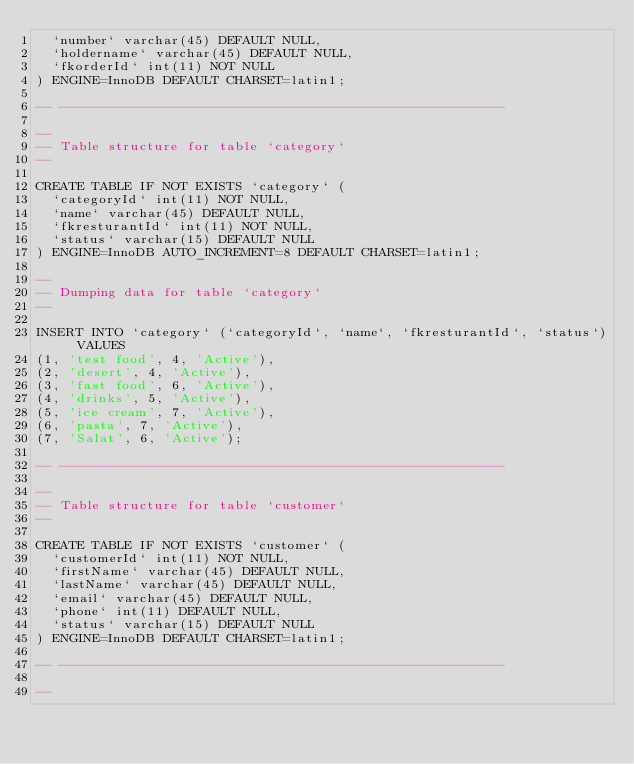<code> <loc_0><loc_0><loc_500><loc_500><_SQL_>  `number` varchar(45) DEFAULT NULL,
  `holdername` varchar(45) DEFAULT NULL,
  `fkorderId` int(11) NOT NULL
) ENGINE=InnoDB DEFAULT CHARSET=latin1;

-- --------------------------------------------------------

--
-- Table structure for table `category`
--

CREATE TABLE IF NOT EXISTS `category` (
  `categoryId` int(11) NOT NULL,
  `name` varchar(45) DEFAULT NULL,
  `fkresturantId` int(11) NOT NULL,
  `status` varchar(15) DEFAULT NULL
) ENGINE=InnoDB AUTO_INCREMENT=8 DEFAULT CHARSET=latin1;

--
-- Dumping data for table `category`
--

INSERT INTO `category` (`categoryId`, `name`, `fkresturantId`, `status`) VALUES
(1, 'test food', 4, 'Active'),
(2, 'desert', 4, 'Active'),
(3, 'fast food', 6, 'Active'),
(4, 'drinks', 5, 'Active'),
(5, 'ice cream', 7, 'Active'),
(6, 'pasta', 7, 'Active'),
(7, 'Salat', 6, 'Active');

-- --------------------------------------------------------

--
-- Table structure for table `customer`
--

CREATE TABLE IF NOT EXISTS `customer` (
  `customerId` int(11) NOT NULL,
  `firstName` varchar(45) DEFAULT NULL,
  `lastName` varchar(45) DEFAULT NULL,
  `email` varchar(45) DEFAULT NULL,
  `phone` int(11) DEFAULT NULL,
  `status` varchar(15) DEFAULT NULL
) ENGINE=InnoDB DEFAULT CHARSET=latin1;

-- --------------------------------------------------------

--</code> 